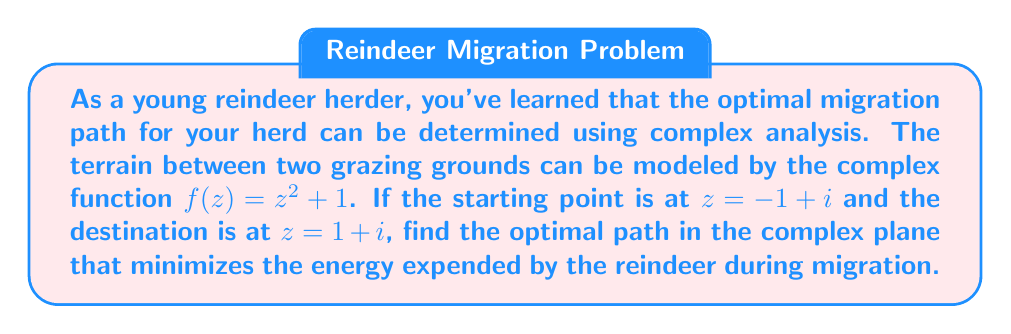Give your solution to this math problem. To solve this problem, we'll use the technique of conformal mapping and the principle that the optimal path in complex analysis is often a straight line in the transformed plane.

1) First, we need to find the inverse function of $f(z) = z^2 + 1$. This is:

   $g(w) = \sqrt{w - 1}$

   Where we choose the principal branch of the square root.

2) Now, we need to map our starting and ending points from the z-plane to the w-plane:

   Start: $f(-1 + i) = (-1 + i)^2 + 1 = 1 - 2i + i^2 + 1 = 1 - 2i - 1 + 1 = -2i$
   End: $f(1 + i) = (1 + i)^2 + 1 = 1 + 2i + i^2 + 1 = 1 + 2i - 1 + 1 = 2 + 2i$

3) In the w-plane, the optimal path is a straight line from $-2i$ to $2 + 2i$. We can parametrize this line as:

   $w(t) = -2i + t(2 + 4i)$, where $0 \leq t \leq 1$

4) To get the optimal path in the z-plane, we apply the inverse function $g$ to this line:

   $z(t) = g(w(t)) = \sqrt{-2i + t(2 + 4i) - 1}$
         $= \sqrt{-1 - 2i + 2t + 4ti}$
         $= \sqrt{(2t - 1) + (4t - 2)i}$

5) This gives us a parametric equation for the optimal path in the z-plane. We can verify that:

   At $t = 0$: $z(0) = \sqrt{-1 - 2i} = -1 + i$ (our starting point)
   At $t = 1$: $z(1) = \sqrt{1 + 2i} = 1 + i$ (our ending point)
Answer: The optimal path for reindeer migration in the complex plane is given by the parametric equation:

$z(t) = \sqrt{(2t - 1) + (4t - 2)i}$

where $0 \leq t \leq 1$. 